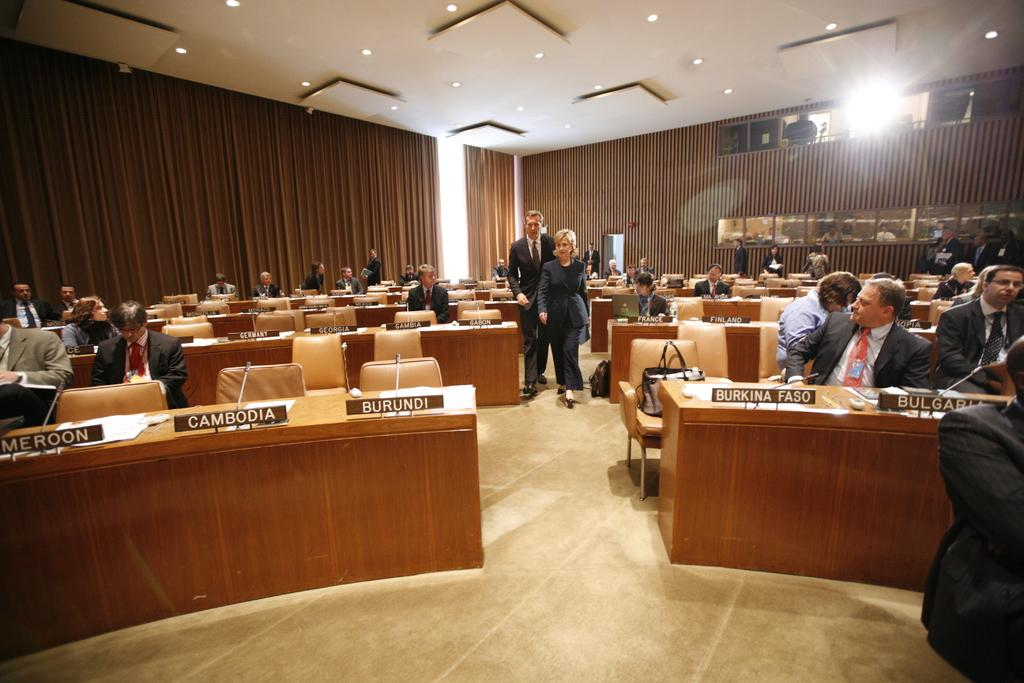What are the people in the image doing? There are people sitting on chairs and standing in the image. What electronic devices can be seen in the image? There are laptops visible in the image. What type of writing material is present in the image? There are papers in the image. What equipment is used for amplifying sound in the image? There are microphones (mics) in the image. What type of surface is present for writing or displaying information in the image? There are boards in the image. What is the color of the background in the image? The background of the image is brown in color. What type of lighting is visible in the image? There are lights visible in the image. Can you tell me how many grapes are on the table in the image? There are no grapes present in the image. What type of prison is depicted in the image? There is no prison depicted in the image. 